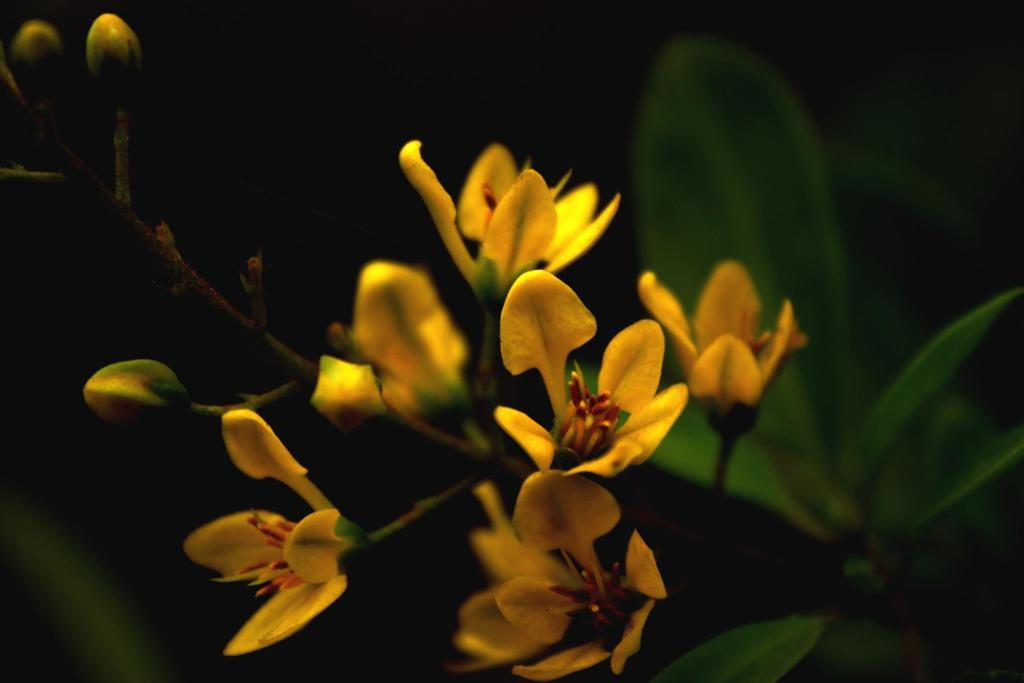What type of living organism is present in the image? There is a plant in the image. What specific feature of the plant can be observed? The plant has flowers. Where is the plant located in the image? The plant is located in the center of the image. How many baby tickets can be seen in the image? There are no baby tickets present in the image. The image features a plant with flowers and does not include any tickets or references to babies. 